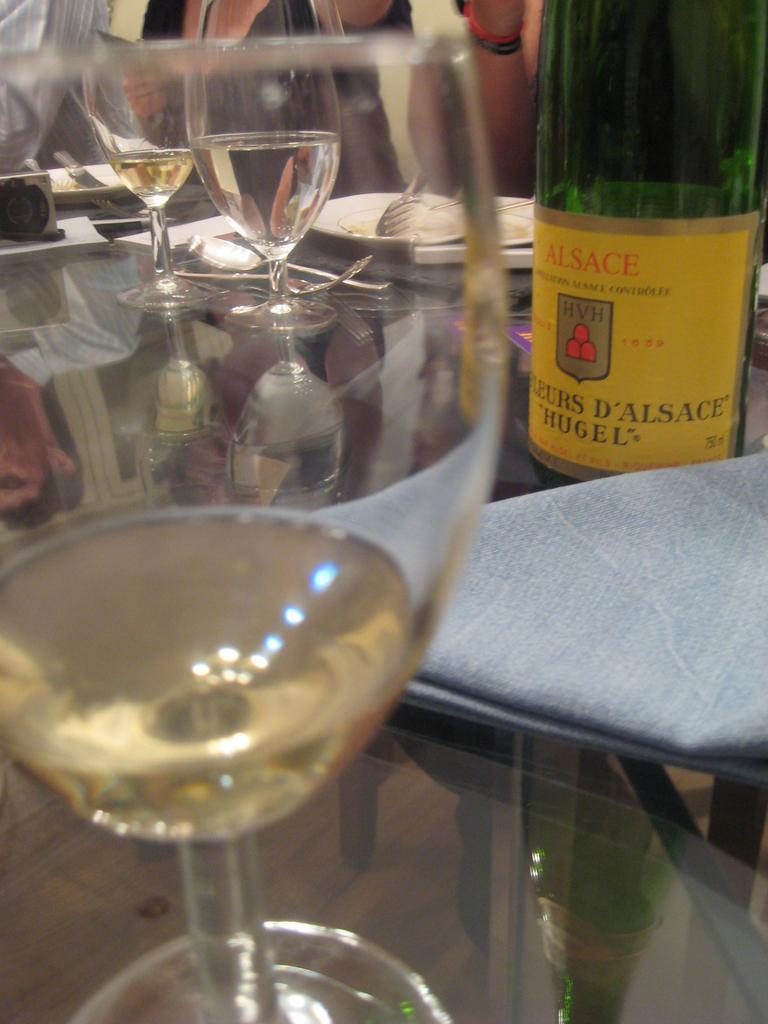What type of beverage is in the glasses in the image? There are glasses of wine in the image. What is the source of the wine in the image? There is a wine bottle in the image. Where are the glasses and bottle located in the image? The glasses and bottle are on a table. What is the plot of the story unfolding in the image? There is no story or plot depicted in the image; it simply shows glasses of wine and a wine bottle on a table. 